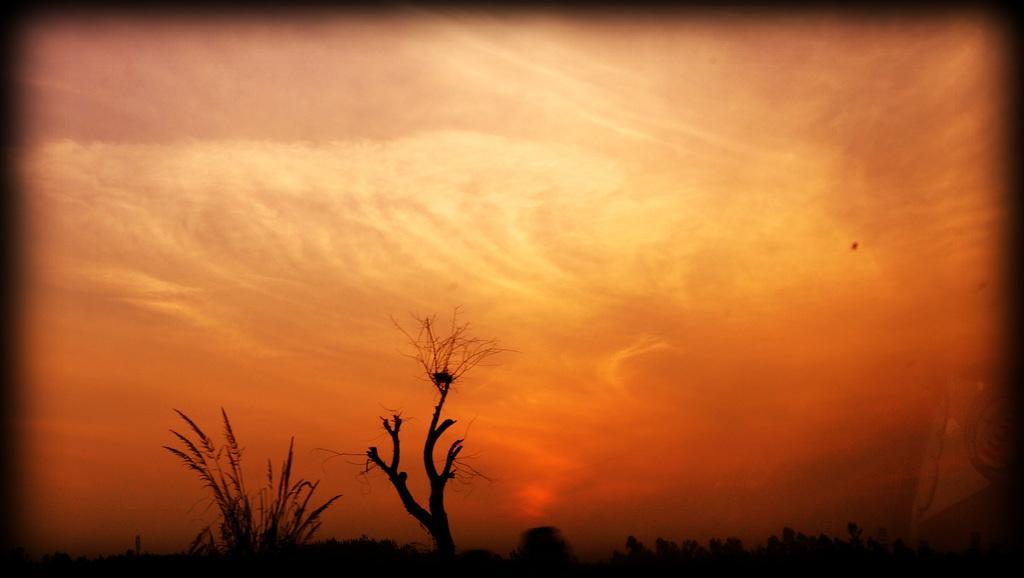Describe this image in one or two sentences. In this image at the bottom we can see a bare tree, grass and plants. In the background we can see clouds in the sky. This image is edited with a frame. 